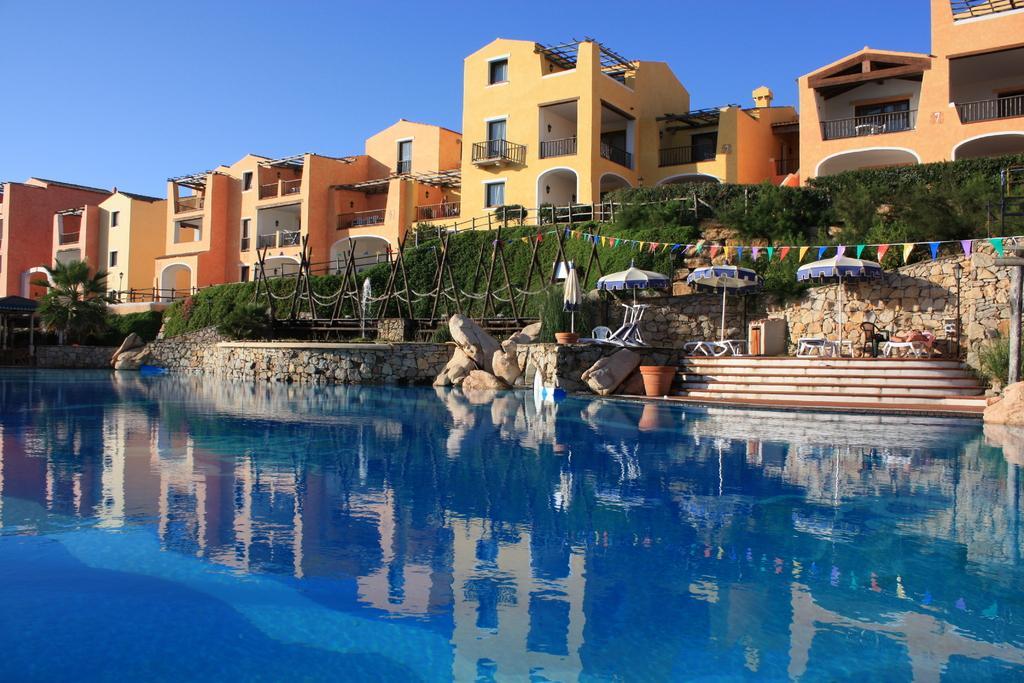How would you summarize this image in a sentence or two? In this picture we can see, it looks like a swimming pool. Behind the swimming pool there are rocks, poles, chairs, tables, umbrella shaped items and some decorative items. Behind the poles there is a tree, grass, buildings and the sky. 